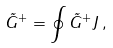Convert formula to latex. <formula><loc_0><loc_0><loc_500><loc_500>\tilde { G } ^ { + } = \oint \tilde { G } ^ { + } J \, ,</formula> 